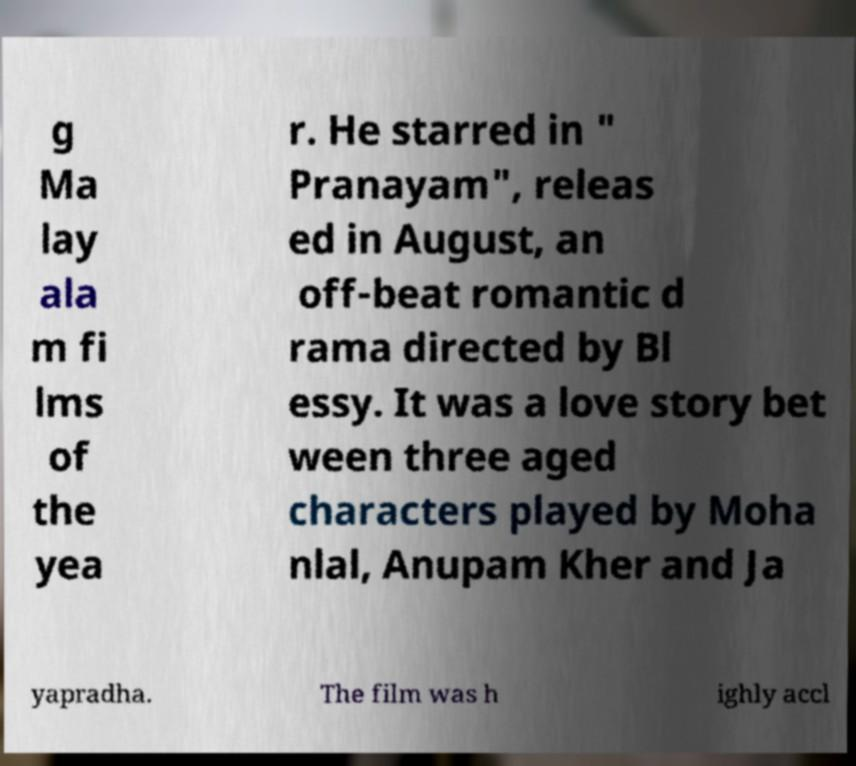Could you assist in decoding the text presented in this image and type it out clearly? g Ma lay ala m fi lms of the yea r. He starred in " Pranayam", releas ed in August, an off-beat romantic d rama directed by Bl essy. It was a love story bet ween three aged characters played by Moha nlal, Anupam Kher and Ja yapradha. The film was h ighly accl 